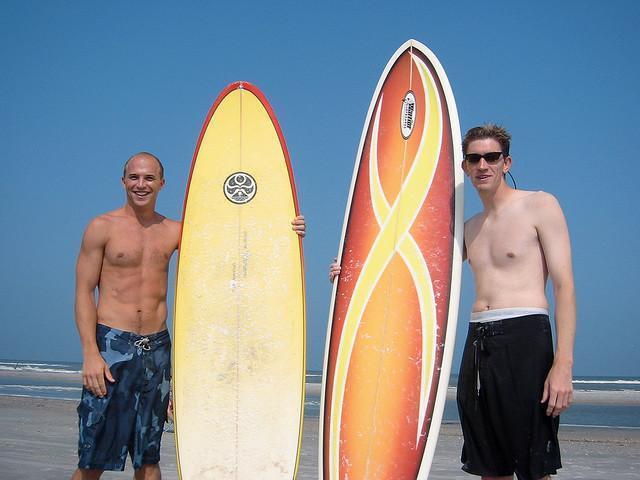How many people can be seen?
Give a very brief answer. 2. How many surfboards can you see?
Give a very brief answer. 2. 